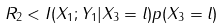<formula> <loc_0><loc_0><loc_500><loc_500>R _ { 2 } < I ( X _ { 1 } ; Y _ { 1 } | X _ { 3 } = l ) p ( X _ { 3 } = l )</formula> 